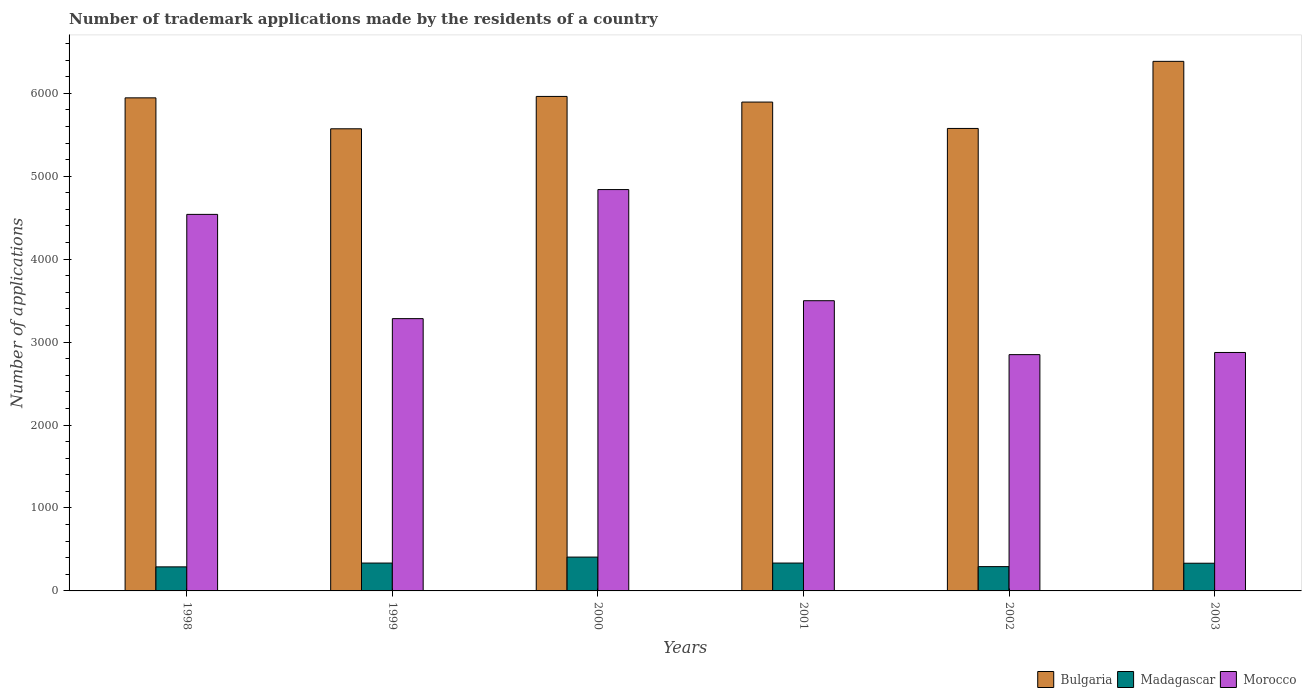How many groups of bars are there?
Your answer should be very brief. 6. Are the number of bars per tick equal to the number of legend labels?
Provide a short and direct response. Yes. What is the number of trademark applications made by the residents in Bulgaria in 2003?
Offer a very short reply. 6385. Across all years, what is the maximum number of trademark applications made by the residents in Madagascar?
Make the answer very short. 408. Across all years, what is the minimum number of trademark applications made by the residents in Bulgaria?
Your response must be concise. 5572. In which year was the number of trademark applications made by the residents in Bulgaria minimum?
Your answer should be compact. 1999. What is the total number of trademark applications made by the residents in Bulgaria in the graph?
Ensure brevity in your answer.  3.53e+04. What is the difference between the number of trademark applications made by the residents in Morocco in 2001 and that in 2002?
Provide a short and direct response. 650. What is the difference between the number of trademark applications made by the residents in Morocco in 2000 and the number of trademark applications made by the residents in Bulgaria in 2003?
Your answer should be compact. -1546. What is the average number of trademark applications made by the residents in Morocco per year?
Offer a very short reply. 3647.5. In the year 2000, what is the difference between the number of trademark applications made by the residents in Morocco and number of trademark applications made by the residents in Madagascar?
Your answer should be compact. 4431. In how many years, is the number of trademark applications made by the residents in Madagascar greater than 3200?
Provide a short and direct response. 0. What is the ratio of the number of trademark applications made by the residents in Madagascar in 2000 to that in 2001?
Give a very brief answer. 1.21. Is the difference between the number of trademark applications made by the residents in Morocco in 2001 and 2002 greater than the difference between the number of trademark applications made by the residents in Madagascar in 2001 and 2002?
Your answer should be compact. Yes. What is the difference between the highest and the second highest number of trademark applications made by the residents in Madagascar?
Offer a very short reply. 72. What is the difference between the highest and the lowest number of trademark applications made by the residents in Madagascar?
Ensure brevity in your answer.  118. What does the 2nd bar from the left in 1998 represents?
Your response must be concise. Madagascar. What does the 1st bar from the right in 2002 represents?
Your answer should be very brief. Morocco. How many years are there in the graph?
Keep it short and to the point. 6. Where does the legend appear in the graph?
Your answer should be compact. Bottom right. How many legend labels are there?
Your response must be concise. 3. How are the legend labels stacked?
Ensure brevity in your answer.  Horizontal. What is the title of the graph?
Provide a succinct answer. Number of trademark applications made by the residents of a country. Does "Trinidad and Tobago" appear as one of the legend labels in the graph?
Keep it short and to the point. No. What is the label or title of the X-axis?
Ensure brevity in your answer.  Years. What is the label or title of the Y-axis?
Offer a terse response. Number of applications. What is the Number of applications in Bulgaria in 1998?
Ensure brevity in your answer.  5945. What is the Number of applications in Madagascar in 1998?
Your answer should be compact. 290. What is the Number of applications of Morocco in 1998?
Your answer should be compact. 4540. What is the Number of applications of Bulgaria in 1999?
Keep it short and to the point. 5572. What is the Number of applications of Madagascar in 1999?
Ensure brevity in your answer.  336. What is the Number of applications of Morocco in 1999?
Provide a short and direct response. 3283. What is the Number of applications of Bulgaria in 2000?
Your answer should be compact. 5962. What is the Number of applications of Madagascar in 2000?
Keep it short and to the point. 408. What is the Number of applications in Morocco in 2000?
Offer a terse response. 4839. What is the Number of applications of Bulgaria in 2001?
Make the answer very short. 5894. What is the Number of applications of Madagascar in 2001?
Give a very brief answer. 336. What is the Number of applications in Morocco in 2001?
Your answer should be compact. 3499. What is the Number of applications in Bulgaria in 2002?
Make the answer very short. 5576. What is the Number of applications of Madagascar in 2002?
Ensure brevity in your answer.  293. What is the Number of applications of Morocco in 2002?
Offer a terse response. 2849. What is the Number of applications of Bulgaria in 2003?
Make the answer very short. 6385. What is the Number of applications of Madagascar in 2003?
Your answer should be compact. 334. What is the Number of applications in Morocco in 2003?
Provide a succinct answer. 2875. Across all years, what is the maximum Number of applications of Bulgaria?
Keep it short and to the point. 6385. Across all years, what is the maximum Number of applications in Madagascar?
Your response must be concise. 408. Across all years, what is the maximum Number of applications of Morocco?
Offer a very short reply. 4839. Across all years, what is the minimum Number of applications in Bulgaria?
Offer a terse response. 5572. Across all years, what is the minimum Number of applications of Madagascar?
Ensure brevity in your answer.  290. Across all years, what is the minimum Number of applications of Morocco?
Offer a terse response. 2849. What is the total Number of applications of Bulgaria in the graph?
Make the answer very short. 3.53e+04. What is the total Number of applications in Madagascar in the graph?
Ensure brevity in your answer.  1997. What is the total Number of applications of Morocco in the graph?
Offer a terse response. 2.19e+04. What is the difference between the Number of applications in Bulgaria in 1998 and that in 1999?
Your answer should be compact. 373. What is the difference between the Number of applications of Madagascar in 1998 and that in 1999?
Your response must be concise. -46. What is the difference between the Number of applications in Morocco in 1998 and that in 1999?
Provide a short and direct response. 1257. What is the difference between the Number of applications of Madagascar in 1998 and that in 2000?
Provide a succinct answer. -118. What is the difference between the Number of applications in Morocco in 1998 and that in 2000?
Offer a terse response. -299. What is the difference between the Number of applications of Bulgaria in 1998 and that in 2001?
Make the answer very short. 51. What is the difference between the Number of applications in Madagascar in 1998 and that in 2001?
Provide a short and direct response. -46. What is the difference between the Number of applications in Morocco in 1998 and that in 2001?
Ensure brevity in your answer.  1041. What is the difference between the Number of applications in Bulgaria in 1998 and that in 2002?
Give a very brief answer. 369. What is the difference between the Number of applications of Morocco in 1998 and that in 2002?
Provide a succinct answer. 1691. What is the difference between the Number of applications of Bulgaria in 1998 and that in 2003?
Ensure brevity in your answer.  -440. What is the difference between the Number of applications in Madagascar in 1998 and that in 2003?
Keep it short and to the point. -44. What is the difference between the Number of applications in Morocco in 1998 and that in 2003?
Give a very brief answer. 1665. What is the difference between the Number of applications of Bulgaria in 1999 and that in 2000?
Your answer should be very brief. -390. What is the difference between the Number of applications of Madagascar in 1999 and that in 2000?
Keep it short and to the point. -72. What is the difference between the Number of applications in Morocco in 1999 and that in 2000?
Give a very brief answer. -1556. What is the difference between the Number of applications in Bulgaria in 1999 and that in 2001?
Make the answer very short. -322. What is the difference between the Number of applications in Morocco in 1999 and that in 2001?
Offer a terse response. -216. What is the difference between the Number of applications of Bulgaria in 1999 and that in 2002?
Offer a very short reply. -4. What is the difference between the Number of applications of Morocco in 1999 and that in 2002?
Your answer should be very brief. 434. What is the difference between the Number of applications of Bulgaria in 1999 and that in 2003?
Keep it short and to the point. -813. What is the difference between the Number of applications of Morocco in 1999 and that in 2003?
Offer a very short reply. 408. What is the difference between the Number of applications of Madagascar in 2000 and that in 2001?
Make the answer very short. 72. What is the difference between the Number of applications of Morocco in 2000 and that in 2001?
Give a very brief answer. 1340. What is the difference between the Number of applications in Bulgaria in 2000 and that in 2002?
Your response must be concise. 386. What is the difference between the Number of applications of Madagascar in 2000 and that in 2002?
Ensure brevity in your answer.  115. What is the difference between the Number of applications of Morocco in 2000 and that in 2002?
Your response must be concise. 1990. What is the difference between the Number of applications in Bulgaria in 2000 and that in 2003?
Your answer should be very brief. -423. What is the difference between the Number of applications of Morocco in 2000 and that in 2003?
Your response must be concise. 1964. What is the difference between the Number of applications of Bulgaria in 2001 and that in 2002?
Provide a short and direct response. 318. What is the difference between the Number of applications of Madagascar in 2001 and that in 2002?
Make the answer very short. 43. What is the difference between the Number of applications of Morocco in 2001 and that in 2002?
Keep it short and to the point. 650. What is the difference between the Number of applications of Bulgaria in 2001 and that in 2003?
Keep it short and to the point. -491. What is the difference between the Number of applications in Morocco in 2001 and that in 2003?
Make the answer very short. 624. What is the difference between the Number of applications of Bulgaria in 2002 and that in 2003?
Provide a succinct answer. -809. What is the difference between the Number of applications in Madagascar in 2002 and that in 2003?
Ensure brevity in your answer.  -41. What is the difference between the Number of applications of Morocco in 2002 and that in 2003?
Give a very brief answer. -26. What is the difference between the Number of applications in Bulgaria in 1998 and the Number of applications in Madagascar in 1999?
Ensure brevity in your answer.  5609. What is the difference between the Number of applications of Bulgaria in 1998 and the Number of applications of Morocco in 1999?
Your answer should be compact. 2662. What is the difference between the Number of applications of Madagascar in 1998 and the Number of applications of Morocco in 1999?
Ensure brevity in your answer.  -2993. What is the difference between the Number of applications in Bulgaria in 1998 and the Number of applications in Madagascar in 2000?
Provide a succinct answer. 5537. What is the difference between the Number of applications of Bulgaria in 1998 and the Number of applications of Morocco in 2000?
Give a very brief answer. 1106. What is the difference between the Number of applications in Madagascar in 1998 and the Number of applications in Morocco in 2000?
Keep it short and to the point. -4549. What is the difference between the Number of applications in Bulgaria in 1998 and the Number of applications in Madagascar in 2001?
Provide a succinct answer. 5609. What is the difference between the Number of applications of Bulgaria in 1998 and the Number of applications of Morocco in 2001?
Provide a short and direct response. 2446. What is the difference between the Number of applications of Madagascar in 1998 and the Number of applications of Morocco in 2001?
Give a very brief answer. -3209. What is the difference between the Number of applications in Bulgaria in 1998 and the Number of applications in Madagascar in 2002?
Offer a very short reply. 5652. What is the difference between the Number of applications in Bulgaria in 1998 and the Number of applications in Morocco in 2002?
Ensure brevity in your answer.  3096. What is the difference between the Number of applications of Madagascar in 1998 and the Number of applications of Morocco in 2002?
Provide a short and direct response. -2559. What is the difference between the Number of applications of Bulgaria in 1998 and the Number of applications of Madagascar in 2003?
Ensure brevity in your answer.  5611. What is the difference between the Number of applications of Bulgaria in 1998 and the Number of applications of Morocco in 2003?
Your response must be concise. 3070. What is the difference between the Number of applications of Madagascar in 1998 and the Number of applications of Morocco in 2003?
Provide a succinct answer. -2585. What is the difference between the Number of applications of Bulgaria in 1999 and the Number of applications of Madagascar in 2000?
Keep it short and to the point. 5164. What is the difference between the Number of applications in Bulgaria in 1999 and the Number of applications in Morocco in 2000?
Your answer should be very brief. 733. What is the difference between the Number of applications of Madagascar in 1999 and the Number of applications of Morocco in 2000?
Give a very brief answer. -4503. What is the difference between the Number of applications of Bulgaria in 1999 and the Number of applications of Madagascar in 2001?
Offer a very short reply. 5236. What is the difference between the Number of applications of Bulgaria in 1999 and the Number of applications of Morocco in 2001?
Offer a terse response. 2073. What is the difference between the Number of applications in Madagascar in 1999 and the Number of applications in Morocco in 2001?
Offer a terse response. -3163. What is the difference between the Number of applications in Bulgaria in 1999 and the Number of applications in Madagascar in 2002?
Provide a short and direct response. 5279. What is the difference between the Number of applications in Bulgaria in 1999 and the Number of applications in Morocco in 2002?
Your response must be concise. 2723. What is the difference between the Number of applications in Madagascar in 1999 and the Number of applications in Morocco in 2002?
Offer a very short reply. -2513. What is the difference between the Number of applications of Bulgaria in 1999 and the Number of applications of Madagascar in 2003?
Ensure brevity in your answer.  5238. What is the difference between the Number of applications in Bulgaria in 1999 and the Number of applications in Morocco in 2003?
Keep it short and to the point. 2697. What is the difference between the Number of applications of Madagascar in 1999 and the Number of applications of Morocco in 2003?
Your answer should be compact. -2539. What is the difference between the Number of applications in Bulgaria in 2000 and the Number of applications in Madagascar in 2001?
Your answer should be compact. 5626. What is the difference between the Number of applications in Bulgaria in 2000 and the Number of applications in Morocco in 2001?
Your answer should be very brief. 2463. What is the difference between the Number of applications of Madagascar in 2000 and the Number of applications of Morocco in 2001?
Offer a very short reply. -3091. What is the difference between the Number of applications of Bulgaria in 2000 and the Number of applications of Madagascar in 2002?
Provide a succinct answer. 5669. What is the difference between the Number of applications in Bulgaria in 2000 and the Number of applications in Morocco in 2002?
Your response must be concise. 3113. What is the difference between the Number of applications of Madagascar in 2000 and the Number of applications of Morocco in 2002?
Offer a terse response. -2441. What is the difference between the Number of applications in Bulgaria in 2000 and the Number of applications in Madagascar in 2003?
Your answer should be compact. 5628. What is the difference between the Number of applications of Bulgaria in 2000 and the Number of applications of Morocco in 2003?
Your response must be concise. 3087. What is the difference between the Number of applications of Madagascar in 2000 and the Number of applications of Morocco in 2003?
Your response must be concise. -2467. What is the difference between the Number of applications of Bulgaria in 2001 and the Number of applications of Madagascar in 2002?
Your response must be concise. 5601. What is the difference between the Number of applications of Bulgaria in 2001 and the Number of applications of Morocco in 2002?
Your answer should be compact. 3045. What is the difference between the Number of applications of Madagascar in 2001 and the Number of applications of Morocco in 2002?
Ensure brevity in your answer.  -2513. What is the difference between the Number of applications of Bulgaria in 2001 and the Number of applications of Madagascar in 2003?
Offer a terse response. 5560. What is the difference between the Number of applications in Bulgaria in 2001 and the Number of applications in Morocco in 2003?
Make the answer very short. 3019. What is the difference between the Number of applications in Madagascar in 2001 and the Number of applications in Morocco in 2003?
Your answer should be very brief. -2539. What is the difference between the Number of applications of Bulgaria in 2002 and the Number of applications of Madagascar in 2003?
Keep it short and to the point. 5242. What is the difference between the Number of applications in Bulgaria in 2002 and the Number of applications in Morocco in 2003?
Your response must be concise. 2701. What is the difference between the Number of applications of Madagascar in 2002 and the Number of applications of Morocco in 2003?
Ensure brevity in your answer.  -2582. What is the average Number of applications in Bulgaria per year?
Keep it short and to the point. 5889. What is the average Number of applications of Madagascar per year?
Your answer should be compact. 332.83. What is the average Number of applications in Morocco per year?
Your answer should be very brief. 3647.5. In the year 1998, what is the difference between the Number of applications of Bulgaria and Number of applications of Madagascar?
Provide a succinct answer. 5655. In the year 1998, what is the difference between the Number of applications of Bulgaria and Number of applications of Morocco?
Your answer should be very brief. 1405. In the year 1998, what is the difference between the Number of applications of Madagascar and Number of applications of Morocco?
Make the answer very short. -4250. In the year 1999, what is the difference between the Number of applications of Bulgaria and Number of applications of Madagascar?
Provide a succinct answer. 5236. In the year 1999, what is the difference between the Number of applications in Bulgaria and Number of applications in Morocco?
Your answer should be very brief. 2289. In the year 1999, what is the difference between the Number of applications in Madagascar and Number of applications in Morocco?
Your answer should be very brief. -2947. In the year 2000, what is the difference between the Number of applications of Bulgaria and Number of applications of Madagascar?
Provide a succinct answer. 5554. In the year 2000, what is the difference between the Number of applications in Bulgaria and Number of applications in Morocco?
Offer a terse response. 1123. In the year 2000, what is the difference between the Number of applications of Madagascar and Number of applications of Morocco?
Ensure brevity in your answer.  -4431. In the year 2001, what is the difference between the Number of applications in Bulgaria and Number of applications in Madagascar?
Keep it short and to the point. 5558. In the year 2001, what is the difference between the Number of applications of Bulgaria and Number of applications of Morocco?
Ensure brevity in your answer.  2395. In the year 2001, what is the difference between the Number of applications in Madagascar and Number of applications in Morocco?
Offer a very short reply. -3163. In the year 2002, what is the difference between the Number of applications in Bulgaria and Number of applications in Madagascar?
Provide a short and direct response. 5283. In the year 2002, what is the difference between the Number of applications in Bulgaria and Number of applications in Morocco?
Your answer should be very brief. 2727. In the year 2002, what is the difference between the Number of applications of Madagascar and Number of applications of Morocco?
Keep it short and to the point. -2556. In the year 2003, what is the difference between the Number of applications in Bulgaria and Number of applications in Madagascar?
Offer a terse response. 6051. In the year 2003, what is the difference between the Number of applications of Bulgaria and Number of applications of Morocco?
Your response must be concise. 3510. In the year 2003, what is the difference between the Number of applications in Madagascar and Number of applications in Morocco?
Your response must be concise. -2541. What is the ratio of the Number of applications in Bulgaria in 1998 to that in 1999?
Your answer should be compact. 1.07. What is the ratio of the Number of applications in Madagascar in 1998 to that in 1999?
Your answer should be very brief. 0.86. What is the ratio of the Number of applications in Morocco in 1998 to that in 1999?
Your answer should be compact. 1.38. What is the ratio of the Number of applications of Madagascar in 1998 to that in 2000?
Ensure brevity in your answer.  0.71. What is the ratio of the Number of applications of Morocco in 1998 to that in 2000?
Your answer should be very brief. 0.94. What is the ratio of the Number of applications of Bulgaria in 1998 to that in 2001?
Offer a terse response. 1.01. What is the ratio of the Number of applications in Madagascar in 1998 to that in 2001?
Your answer should be very brief. 0.86. What is the ratio of the Number of applications in Morocco in 1998 to that in 2001?
Offer a terse response. 1.3. What is the ratio of the Number of applications of Bulgaria in 1998 to that in 2002?
Your response must be concise. 1.07. What is the ratio of the Number of applications of Morocco in 1998 to that in 2002?
Provide a succinct answer. 1.59. What is the ratio of the Number of applications in Bulgaria in 1998 to that in 2003?
Offer a terse response. 0.93. What is the ratio of the Number of applications of Madagascar in 1998 to that in 2003?
Provide a succinct answer. 0.87. What is the ratio of the Number of applications of Morocco in 1998 to that in 2003?
Offer a very short reply. 1.58. What is the ratio of the Number of applications in Bulgaria in 1999 to that in 2000?
Make the answer very short. 0.93. What is the ratio of the Number of applications of Madagascar in 1999 to that in 2000?
Offer a terse response. 0.82. What is the ratio of the Number of applications in Morocco in 1999 to that in 2000?
Give a very brief answer. 0.68. What is the ratio of the Number of applications in Bulgaria in 1999 to that in 2001?
Your response must be concise. 0.95. What is the ratio of the Number of applications of Madagascar in 1999 to that in 2001?
Provide a succinct answer. 1. What is the ratio of the Number of applications of Morocco in 1999 to that in 2001?
Keep it short and to the point. 0.94. What is the ratio of the Number of applications in Madagascar in 1999 to that in 2002?
Your response must be concise. 1.15. What is the ratio of the Number of applications in Morocco in 1999 to that in 2002?
Make the answer very short. 1.15. What is the ratio of the Number of applications in Bulgaria in 1999 to that in 2003?
Provide a short and direct response. 0.87. What is the ratio of the Number of applications in Madagascar in 1999 to that in 2003?
Offer a terse response. 1.01. What is the ratio of the Number of applications of Morocco in 1999 to that in 2003?
Make the answer very short. 1.14. What is the ratio of the Number of applications in Bulgaria in 2000 to that in 2001?
Provide a short and direct response. 1.01. What is the ratio of the Number of applications of Madagascar in 2000 to that in 2001?
Offer a terse response. 1.21. What is the ratio of the Number of applications of Morocco in 2000 to that in 2001?
Offer a terse response. 1.38. What is the ratio of the Number of applications of Bulgaria in 2000 to that in 2002?
Provide a succinct answer. 1.07. What is the ratio of the Number of applications in Madagascar in 2000 to that in 2002?
Offer a terse response. 1.39. What is the ratio of the Number of applications in Morocco in 2000 to that in 2002?
Your answer should be compact. 1.7. What is the ratio of the Number of applications of Bulgaria in 2000 to that in 2003?
Your answer should be compact. 0.93. What is the ratio of the Number of applications in Madagascar in 2000 to that in 2003?
Offer a very short reply. 1.22. What is the ratio of the Number of applications in Morocco in 2000 to that in 2003?
Make the answer very short. 1.68. What is the ratio of the Number of applications in Bulgaria in 2001 to that in 2002?
Provide a short and direct response. 1.06. What is the ratio of the Number of applications in Madagascar in 2001 to that in 2002?
Ensure brevity in your answer.  1.15. What is the ratio of the Number of applications of Morocco in 2001 to that in 2002?
Your answer should be very brief. 1.23. What is the ratio of the Number of applications of Morocco in 2001 to that in 2003?
Give a very brief answer. 1.22. What is the ratio of the Number of applications of Bulgaria in 2002 to that in 2003?
Provide a short and direct response. 0.87. What is the ratio of the Number of applications in Madagascar in 2002 to that in 2003?
Give a very brief answer. 0.88. What is the ratio of the Number of applications of Morocco in 2002 to that in 2003?
Give a very brief answer. 0.99. What is the difference between the highest and the second highest Number of applications of Bulgaria?
Offer a very short reply. 423. What is the difference between the highest and the second highest Number of applications of Morocco?
Provide a succinct answer. 299. What is the difference between the highest and the lowest Number of applications in Bulgaria?
Your answer should be compact. 813. What is the difference between the highest and the lowest Number of applications in Madagascar?
Give a very brief answer. 118. What is the difference between the highest and the lowest Number of applications in Morocco?
Give a very brief answer. 1990. 